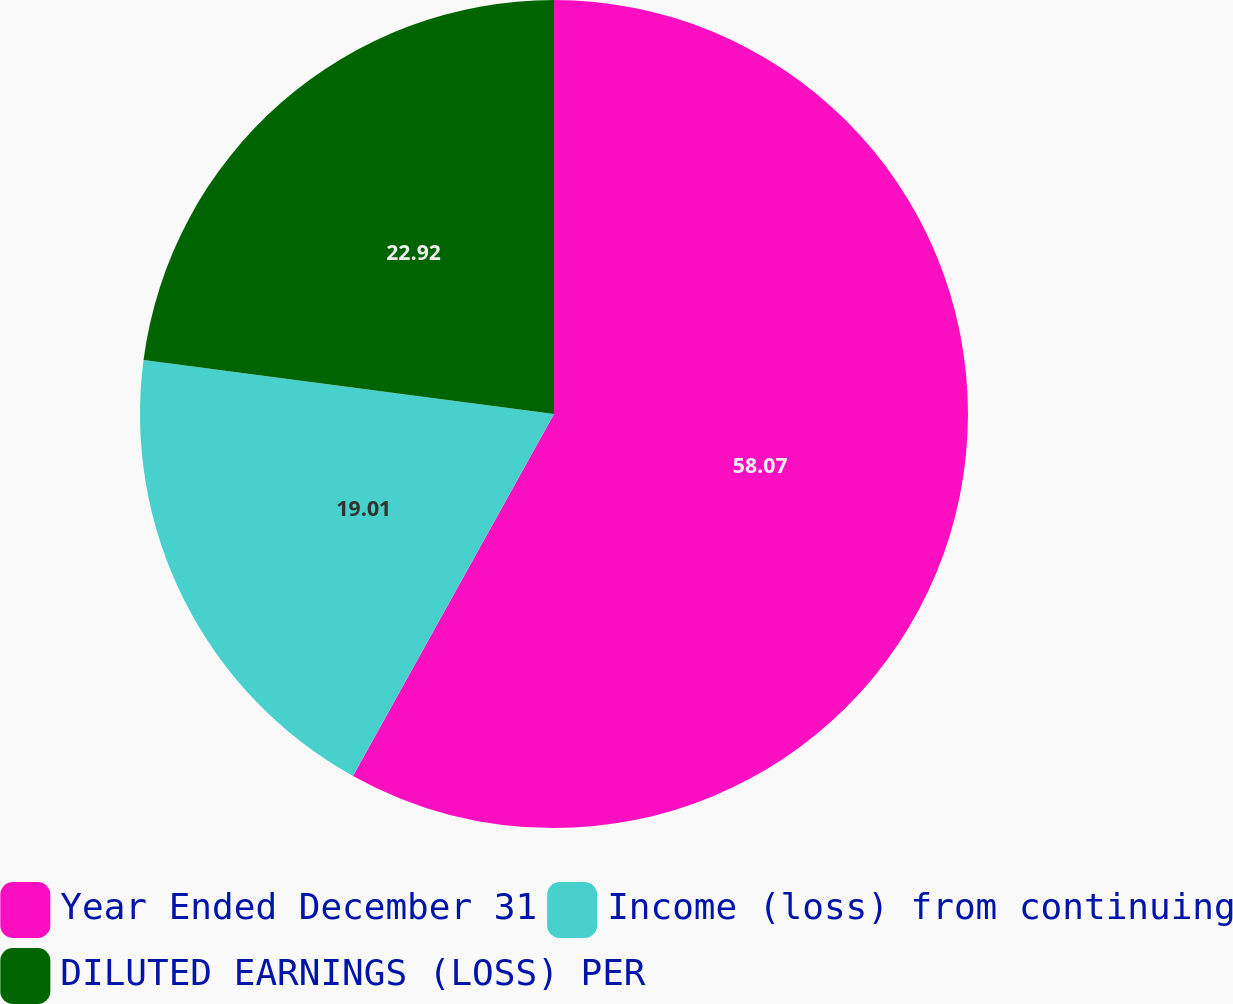Convert chart. <chart><loc_0><loc_0><loc_500><loc_500><pie_chart><fcel>Year Ended December 31<fcel>Income (loss) from continuing<fcel>DILUTED EARNINGS (LOSS) PER<nl><fcel>58.07%<fcel>19.01%<fcel>22.92%<nl></chart> 